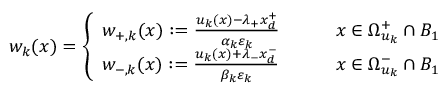Convert formula to latex. <formula><loc_0><loc_0><loc_500><loc_500>w _ { k } ( x ) = \left \{ \begin{array} { l l } { w _ { + , k } ( x ) \colon = \frac { u _ { k } ( x ) - \lambda _ { + } x _ { d } ^ { + } } { \alpha _ { k } \varepsilon _ { k } } \quad } & { x \in \Omega _ { u _ { k } } ^ { + } \cap B _ { 1 } } \\ { w _ { - , k } ( x ) \colon = \frac { u _ { k } ( x ) + \lambda _ { - } x _ { d } ^ { - } } { \beta _ { k } \varepsilon _ { k } } \quad } & { x \in \Omega _ { u _ { k } } ^ { - } \cap B _ { 1 } } \end{array}</formula> 